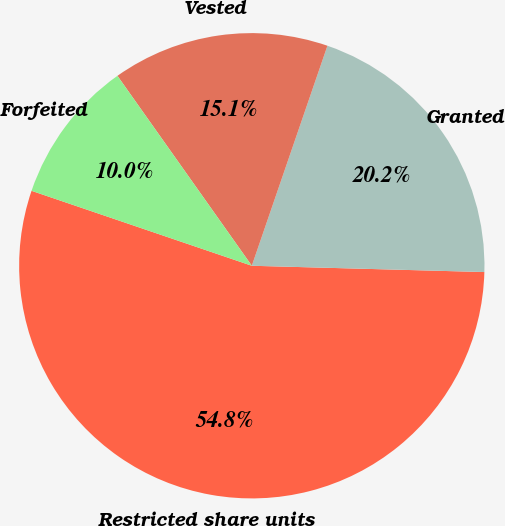Convert chart. <chart><loc_0><loc_0><loc_500><loc_500><pie_chart><fcel>Restricted share units<fcel>Granted<fcel>Vested<fcel>Forfeited<nl><fcel>54.79%<fcel>20.16%<fcel>15.07%<fcel>9.98%<nl></chart> 